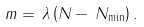<formula> <loc_0><loc_0><loc_500><loc_500>m = \, \lambda \left ( N - \, N _ { \min } \right ) .</formula> 